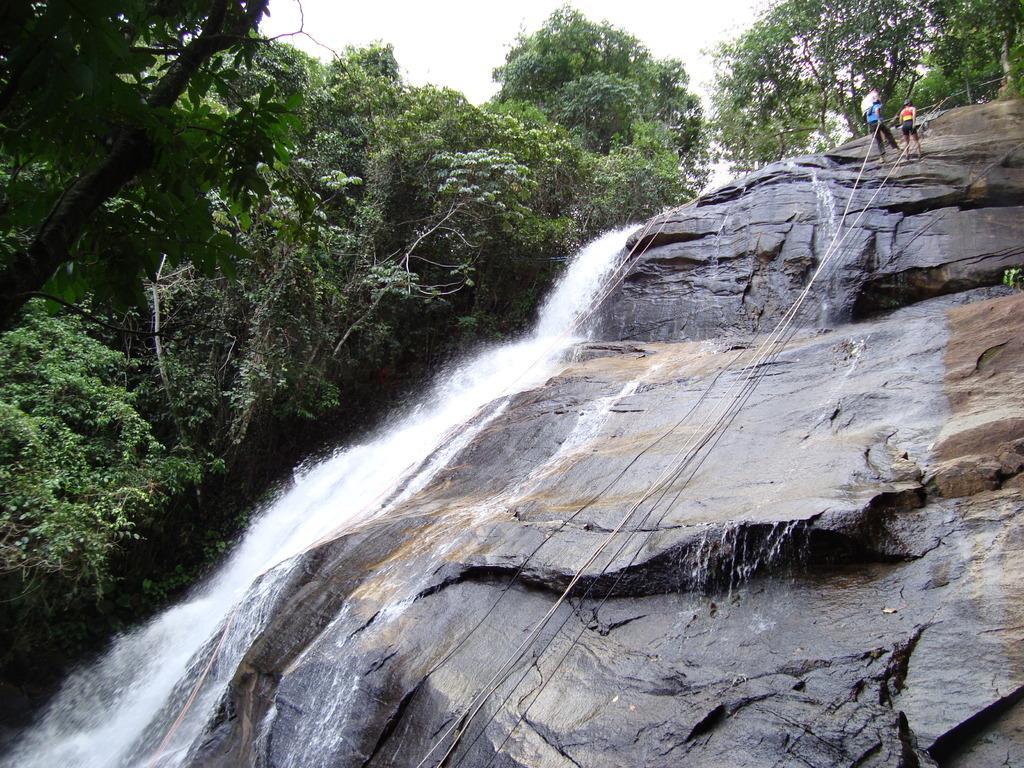Can you describe this image briefly? In this image there is a water fall and trees, also there are people climbing the rock with the help of rope. 